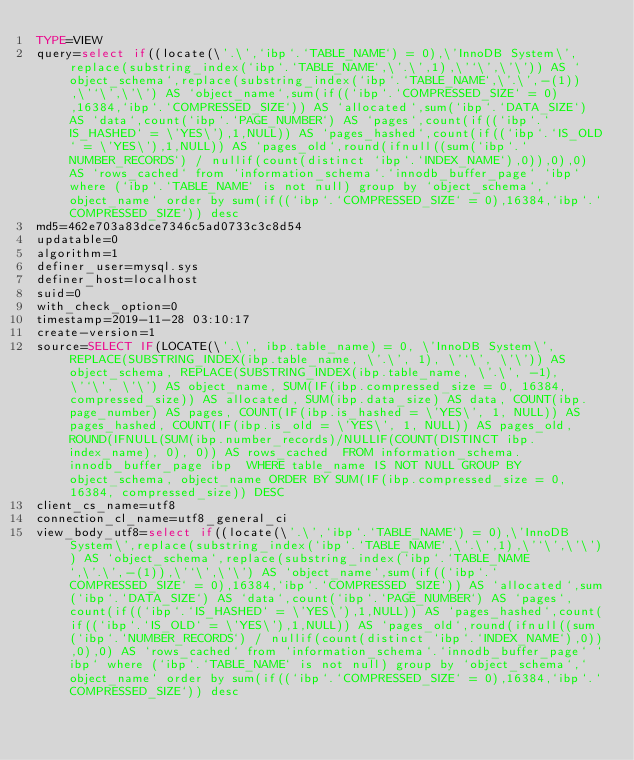Convert code to text. <code><loc_0><loc_0><loc_500><loc_500><_VisualBasic_>TYPE=VIEW
query=select if((locate(\'.\',`ibp`.`TABLE_NAME`) = 0),\'InnoDB System\',replace(substring_index(`ibp`.`TABLE_NAME`,\'.\',1),\'`\',\'\')) AS `object_schema`,replace(substring_index(`ibp`.`TABLE_NAME`,\'.\',-(1)),\'`\',\'\') AS `object_name`,sum(if((`ibp`.`COMPRESSED_SIZE` = 0),16384,`ibp`.`COMPRESSED_SIZE`)) AS `allocated`,sum(`ibp`.`DATA_SIZE`) AS `data`,count(`ibp`.`PAGE_NUMBER`) AS `pages`,count(if((`ibp`.`IS_HASHED` = \'YES\'),1,NULL)) AS `pages_hashed`,count(if((`ibp`.`IS_OLD` = \'YES\'),1,NULL)) AS `pages_old`,round(ifnull((sum(`ibp`.`NUMBER_RECORDS`) / nullif(count(distinct `ibp`.`INDEX_NAME`),0)),0),0) AS `rows_cached` from `information_schema`.`innodb_buffer_page` `ibp` where (`ibp`.`TABLE_NAME` is not null) group by `object_schema`,`object_name` order by sum(if((`ibp`.`COMPRESSED_SIZE` = 0),16384,`ibp`.`COMPRESSED_SIZE`)) desc
md5=462e703a83dce7346c5ad0733c3c8d54
updatable=0
algorithm=1
definer_user=mysql.sys
definer_host=localhost
suid=0
with_check_option=0
timestamp=2019-11-28 03:10:17
create-version=1
source=SELECT IF(LOCATE(\'.\', ibp.table_name) = 0, \'InnoDB System\', REPLACE(SUBSTRING_INDEX(ibp.table_name, \'.\', 1), \'`\', \'\')) AS object_schema, REPLACE(SUBSTRING_INDEX(ibp.table_name, \'.\', -1), \'`\', \'\') AS object_name, SUM(IF(ibp.compressed_size = 0, 16384, compressed_size)) AS allocated, SUM(ibp.data_size) AS data, COUNT(ibp.page_number) AS pages, COUNT(IF(ibp.is_hashed = \'YES\', 1, NULL)) AS pages_hashed, COUNT(IF(ibp.is_old = \'YES\', 1, NULL)) AS pages_old, ROUND(IFNULL(SUM(ibp.number_records)/NULLIF(COUNT(DISTINCT ibp.index_name), 0), 0)) AS rows_cached  FROM information_schema.innodb_buffer_page ibp  WHERE table_name IS NOT NULL GROUP BY object_schema, object_name ORDER BY SUM(IF(ibp.compressed_size = 0, 16384, compressed_size)) DESC
client_cs_name=utf8
connection_cl_name=utf8_general_ci
view_body_utf8=select if((locate(\'.\',`ibp`.`TABLE_NAME`) = 0),\'InnoDB System\',replace(substring_index(`ibp`.`TABLE_NAME`,\'.\',1),\'`\',\'\')) AS `object_schema`,replace(substring_index(`ibp`.`TABLE_NAME`,\'.\',-(1)),\'`\',\'\') AS `object_name`,sum(if((`ibp`.`COMPRESSED_SIZE` = 0),16384,`ibp`.`COMPRESSED_SIZE`)) AS `allocated`,sum(`ibp`.`DATA_SIZE`) AS `data`,count(`ibp`.`PAGE_NUMBER`) AS `pages`,count(if((`ibp`.`IS_HASHED` = \'YES\'),1,NULL)) AS `pages_hashed`,count(if((`ibp`.`IS_OLD` = \'YES\'),1,NULL)) AS `pages_old`,round(ifnull((sum(`ibp`.`NUMBER_RECORDS`) / nullif(count(distinct `ibp`.`INDEX_NAME`),0)),0),0) AS `rows_cached` from `information_schema`.`innodb_buffer_page` `ibp` where (`ibp`.`TABLE_NAME` is not null) group by `object_schema`,`object_name` order by sum(if((`ibp`.`COMPRESSED_SIZE` = 0),16384,`ibp`.`COMPRESSED_SIZE`)) desc
</code> 